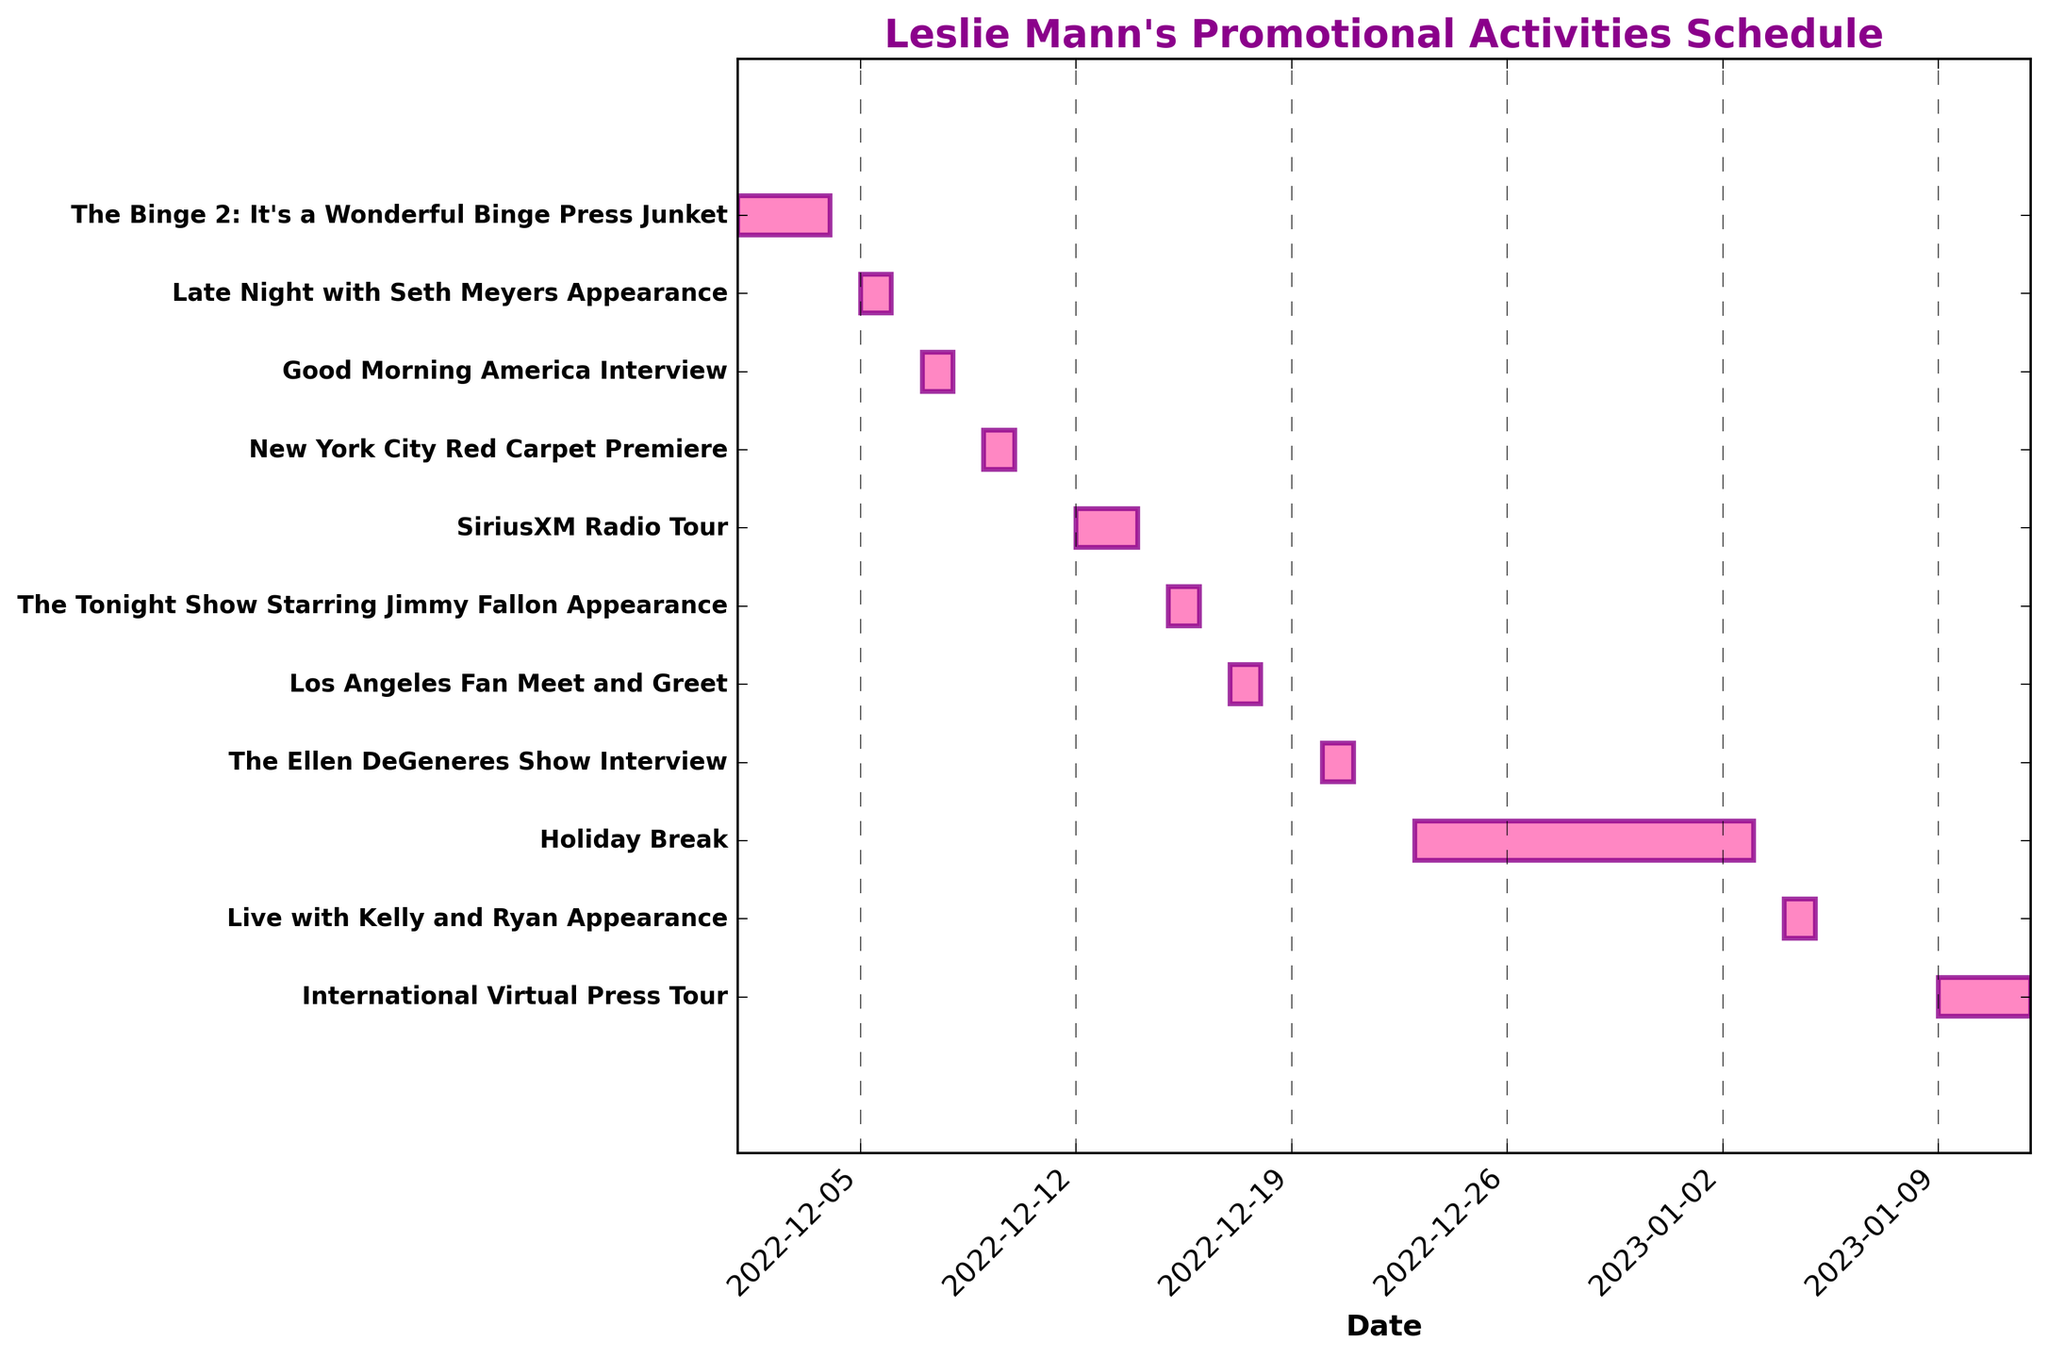When does Leslie Mann's "Holiday Break" start and end? The "Holiday Break" is listed with both a start and end date on the Gantt chart. To find it, locate the "Holiday Break" task on the y-axis and read its corresponding start and end dates.
Answer: December 23, 2022, to January 2, 2023 How many days does the "SiriusXM Radio Tour" last? The duration of the "SiriusXM Radio Tour" can be determined by reading its start and end dates on the Gantt chart, then calculating the difference plus one day.
Answer: 2 days Which event is scheduled immediately after the New York City Red Carpet Premiere? To find the event scheduled right after the New York City Red Carpet Premiere, look at the next task listed on the Gantt chart following its end date.
Answer: SiriusXM Radio Tour How many events are scheduled in December? By counting all the tasks with both their start and end dates in December, you can determine the number of events scheduled in that month.
Answer: 8 events Is there any promotional activity scheduled on December 10, 2022? To determine this, check the Gantt chart for any task bars that start or run through December 10, 2022.
Answer: No Which appearance takes place closer to the new year, "The Ellen DeGeneres Show" or "Live with Kelly and Ryan"? Compare the dates for both show appearances on the Gantt chart to determine which one is closer to January 1, 2023.
Answer: "The Ellen DeGeneres Show" How many activities last exactly one day? Count the number of tasks with a start date equal to their end date, indicating they last only one day.
Answer: 6 activities What is the longest single promotional activity period? To find the longest individual task, compare the duration (difference between start and end dates plus one) of each task on the Gantt chart.
Answer: Holiday Break During which month does the International Virtual Press Tour take place? Identify the start and end dates of the International Virtual Press Tour on the Gantt chart, and see which month these dates fall into.
Answer: January Which event immediately follows after Leslie Mann's "Late Night with Seth Meyers" appearance? Check the next consecutive task on the Gantt chart after the "Late Night with Seth Meyers" date to find the subsequent event.
Answer: "Good Morning America" Interview 